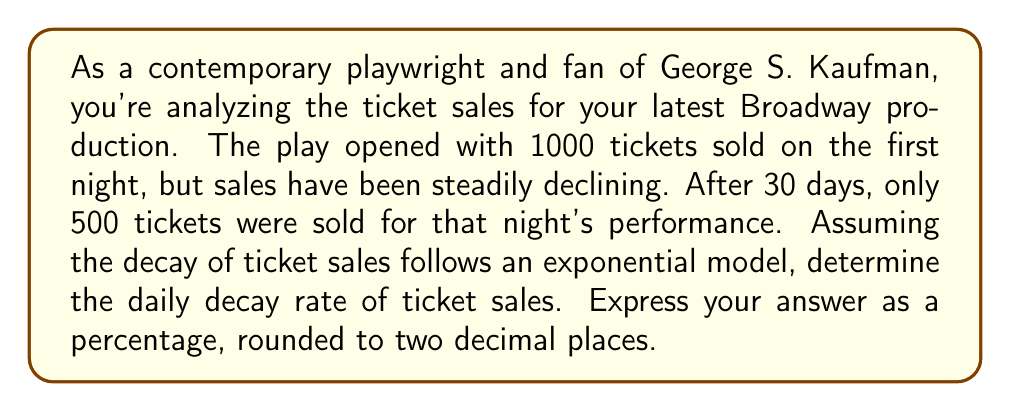What is the answer to this math problem? Let's approach this step-by-step using the exponential decay formula:

1) The general form of exponential decay is:
   $$ N(t) = N_0 \cdot e^{-rt} $$
   where $N(t)$ is the quantity at time $t$, $N_0$ is the initial quantity, $r$ is the decay rate, and $t$ is time.

2) We know:
   - Initial ticket sales, $N_0 = 1000$
   - After 30 days, $N(30) = 500$
   - Time, $t = 30$ days

3) Let's plug these into our formula:
   $$ 500 = 1000 \cdot e^{-r \cdot 30} $$

4) Simplify:
   $$ \frac{1}{2} = e^{-30r} $$

5) Take the natural log of both sides:
   $$ \ln(\frac{1}{2}) = -30r $$

6) Solve for $r$:
   $$ r = -\frac{\ln(\frac{1}{2})}{30} = \frac{\ln(2)}{30} $$

7) Calculate $r$:
   $$ r = \frac{0.693147...}{30} \approx 0.0231049... $$

8) Convert to a percentage:
   $$ 0.0231049... \times 100\% \approx 2.31\% $$
Answer: The daily decay rate of ticket sales is approximately 2.31%. 